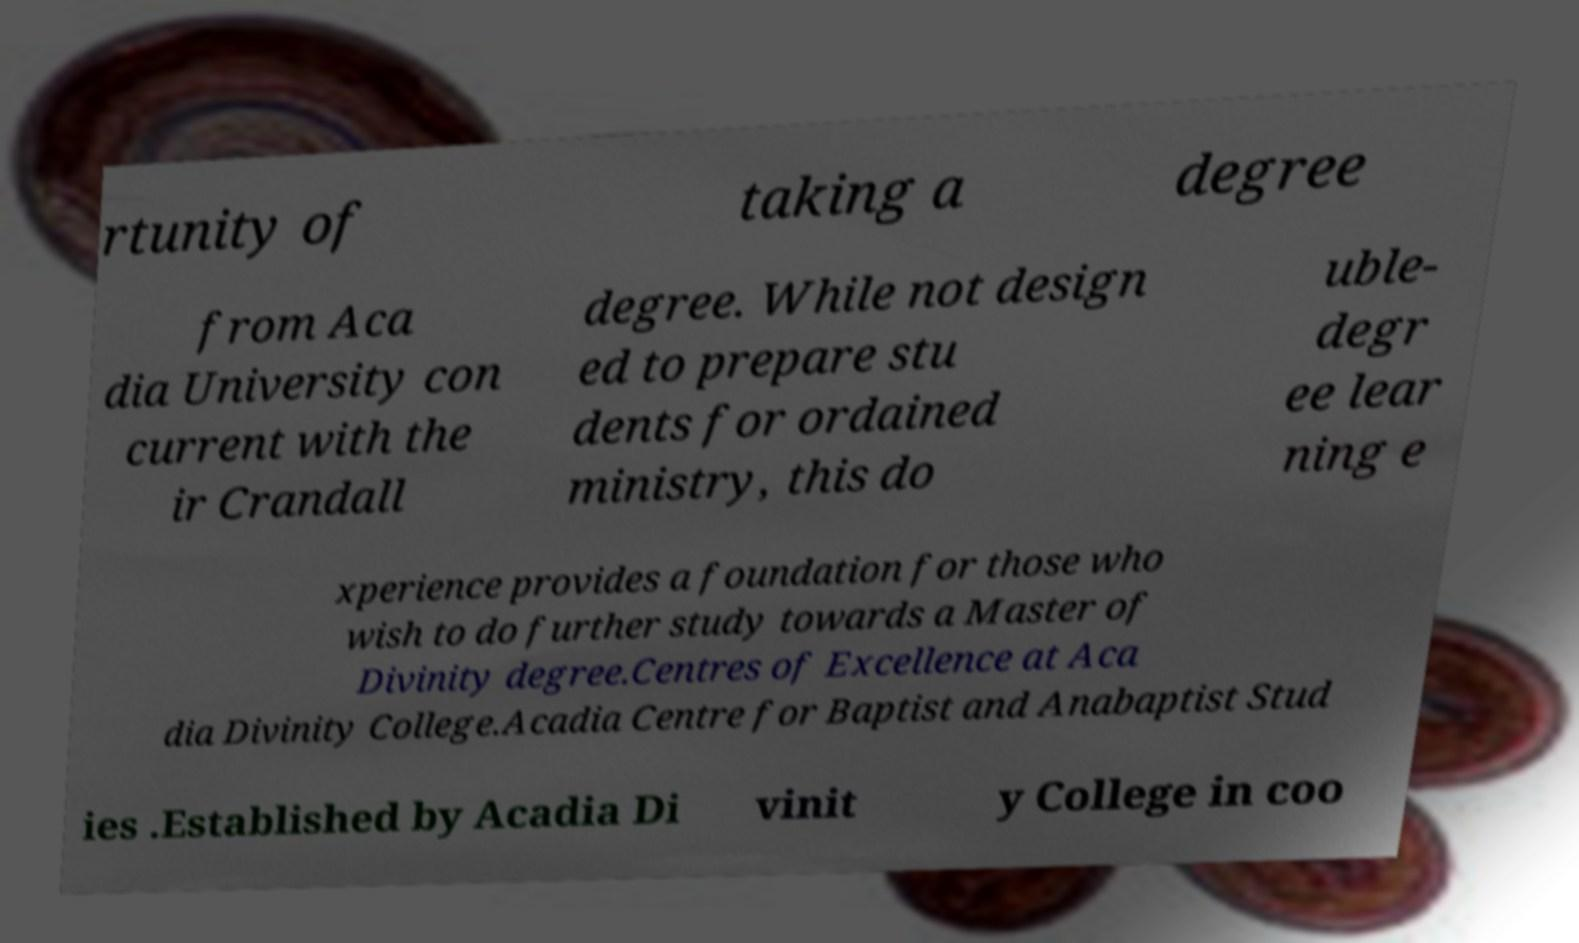There's text embedded in this image that I need extracted. Can you transcribe it verbatim? rtunity of taking a degree from Aca dia University con current with the ir Crandall degree. While not design ed to prepare stu dents for ordained ministry, this do uble- degr ee lear ning e xperience provides a foundation for those who wish to do further study towards a Master of Divinity degree.Centres of Excellence at Aca dia Divinity College.Acadia Centre for Baptist and Anabaptist Stud ies .Established by Acadia Di vinit y College in coo 